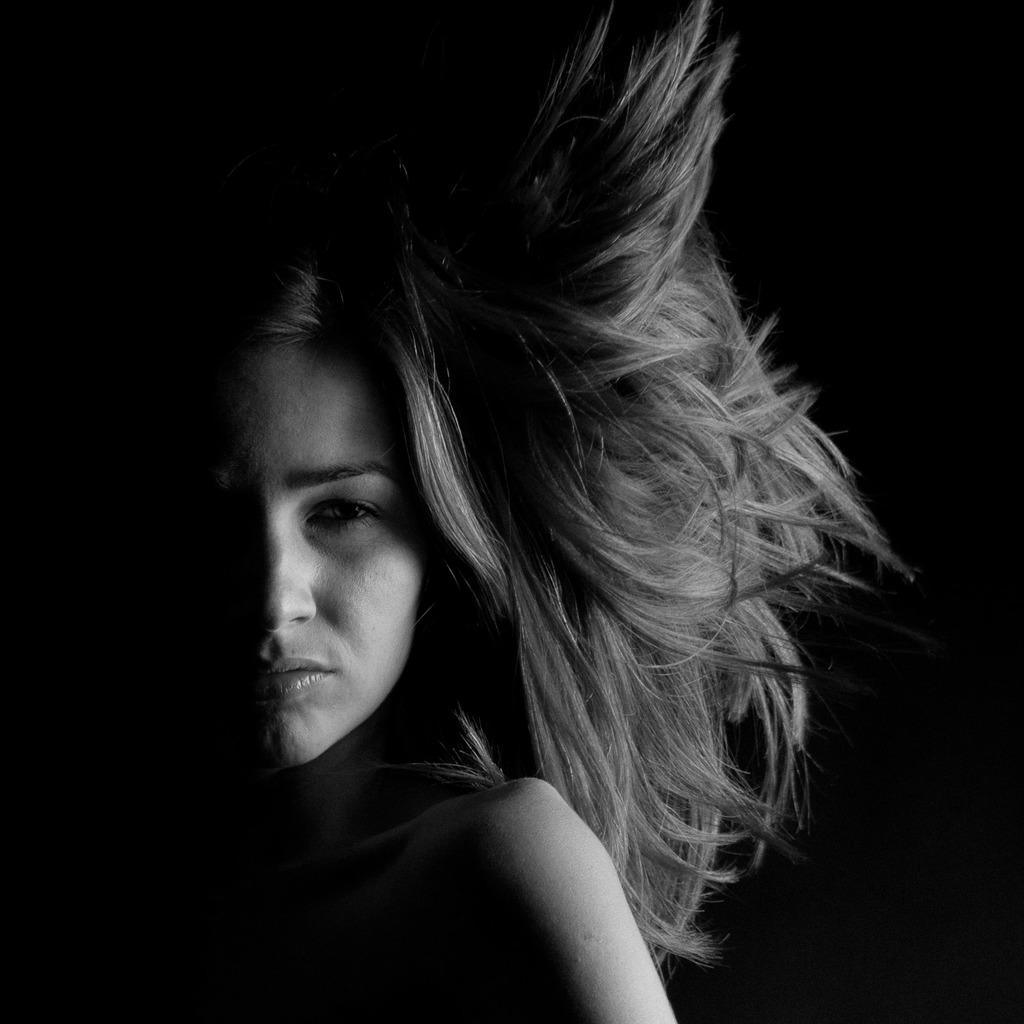Who is present in the image? There is a woman in the image. What can be said about the overall color of the image? The image has a dark color. What type of unit is being measured by the lamp in the image? There is no lamp present in the image, so it is not possible to determine what type of unit is being measured. 